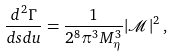Convert formula to latex. <formula><loc_0><loc_0><loc_500><loc_500>\frac { d ^ { 2 } \Gamma } { d s d u } = \frac { 1 } { 2 ^ { 8 } \pi ^ { 3 } M _ { \eta } ^ { 3 } } | \mathcal { M } | ^ { 2 } \, ,</formula> 